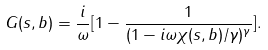<formula> <loc_0><loc_0><loc_500><loc_500>G ( s , b ) = \frac { i } { \omega } [ 1 - \frac { 1 } { ( 1 - i \omega { \chi } ( s , b ) / \gamma ) ^ { \gamma } } ] .</formula> 